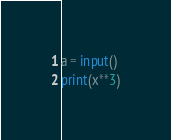Convert code to text. <code><loc_0><loc_0><loc_500><loc_500><_Python_>a = input()
print(x**3)

</code> 